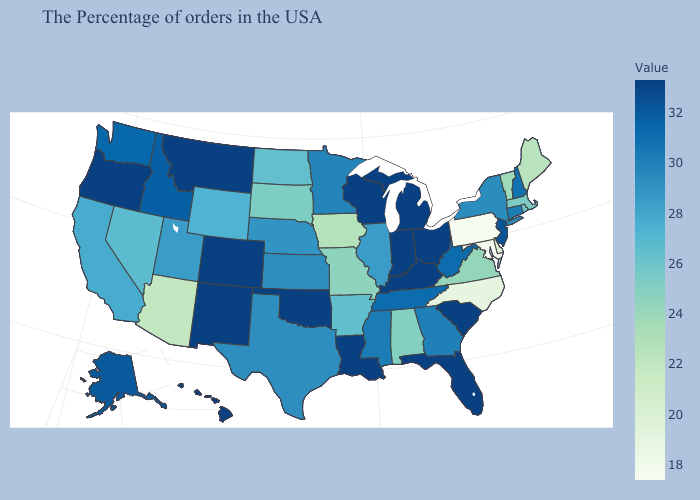Does Maryland have the highest value in the USA?
Concise answer only. No. Does the map have missing data?
Quick response, please. No. Does Alaska have the lowest value in the USA?
Answer briefly. No. Which states have the lowest value in the MidWest?
Give a very brief answer. Iowa. Does Pennsylvania have the lowest value in the USA?
Write a very short answer. Yes. Among the states that border California , which have the lowest value?
Write a very short answer. Arizona. Does Connecticut have the highest value in the Northeast?
Concise answer only. No. 